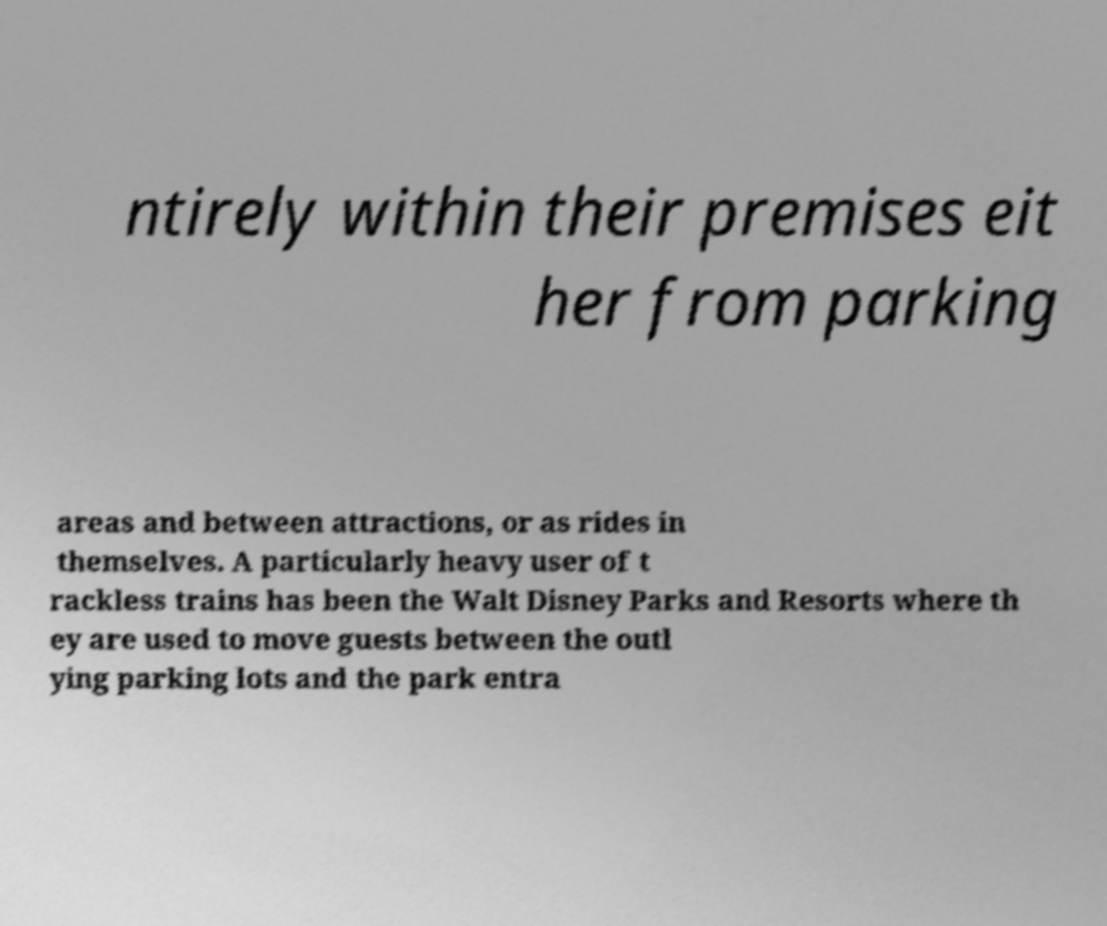What messages or text are displayed in this image? I need them in a readable, typed format. ntirely within their premises eit her from parking areas and between attractions, or as rides in themselves. A particularly heavy user of t rackless trains has been the Walt Disney Parks and Resorts where th ey are used to move guests between the outl ying parking lots and the park entra 